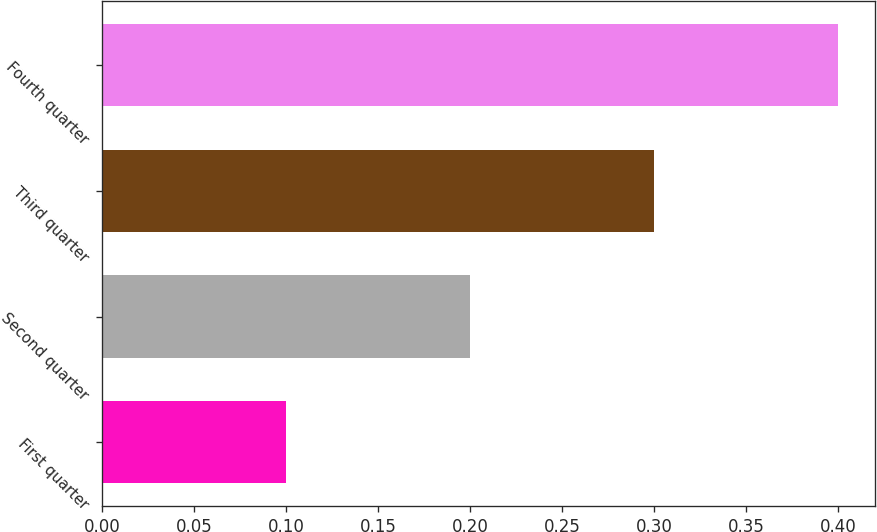<chart> <loc_0><loc_0><loc_500><loc_500><bar_chart><fcel>First quarter<fcel>Second quarter<fcel>Third quarter<fcel>Fourth quarter<nl><fcel>0.1<fcel>0.2<fcel>0.3<fcel>0.4<nl></chart> 